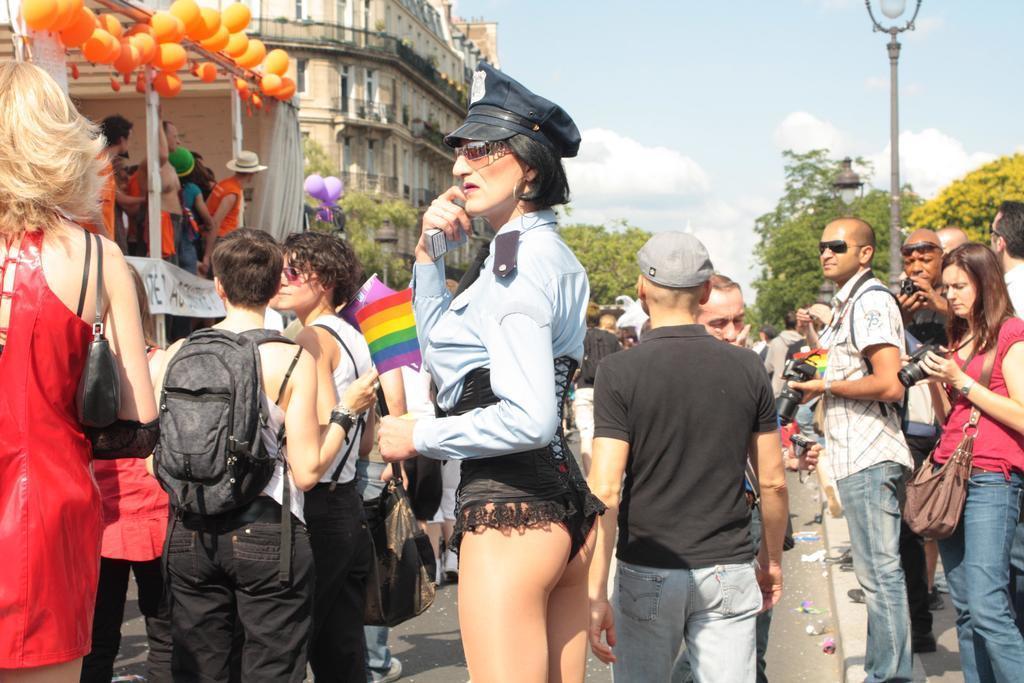In one or two sentences, can you explain what this image depicts? In this image people are standing on the road. At the left side of the image there are orange balloons. At the background there are buildings, trees and lights. At the top there is sky. 